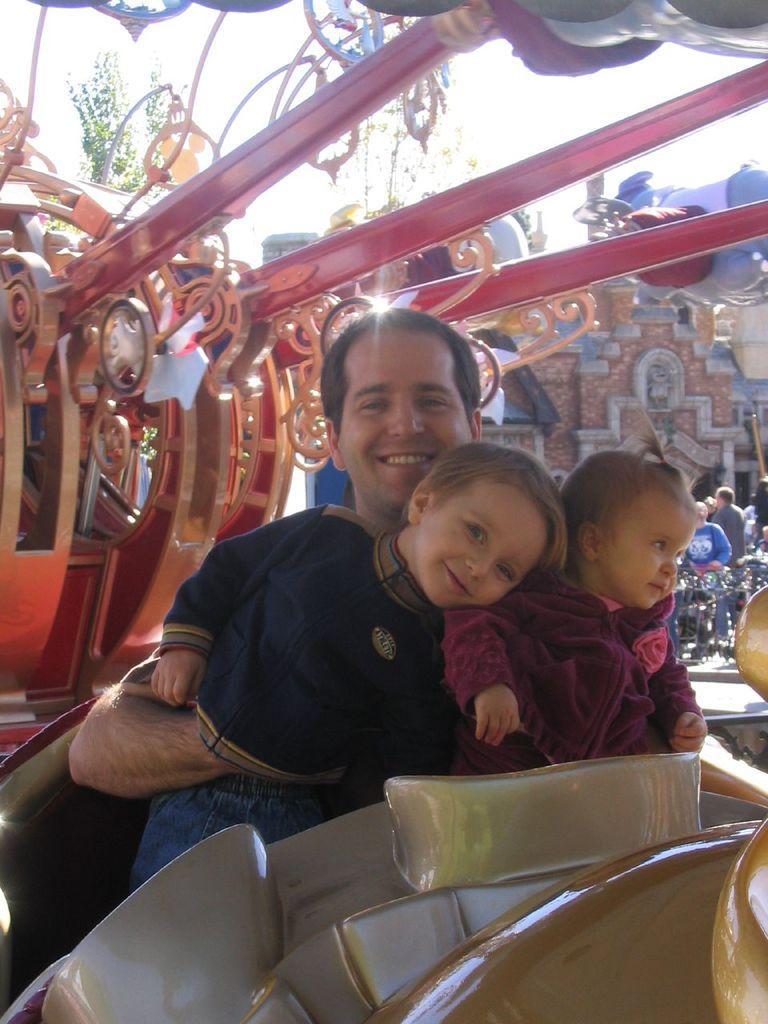Describe this image in one or two sentences. In this image there is a man sitting in the vehicle by holding the two kids. It looks like a fun ride. In the background there are buildings. In front of the buildings there are few people. This image is clicked in the exhibition. 